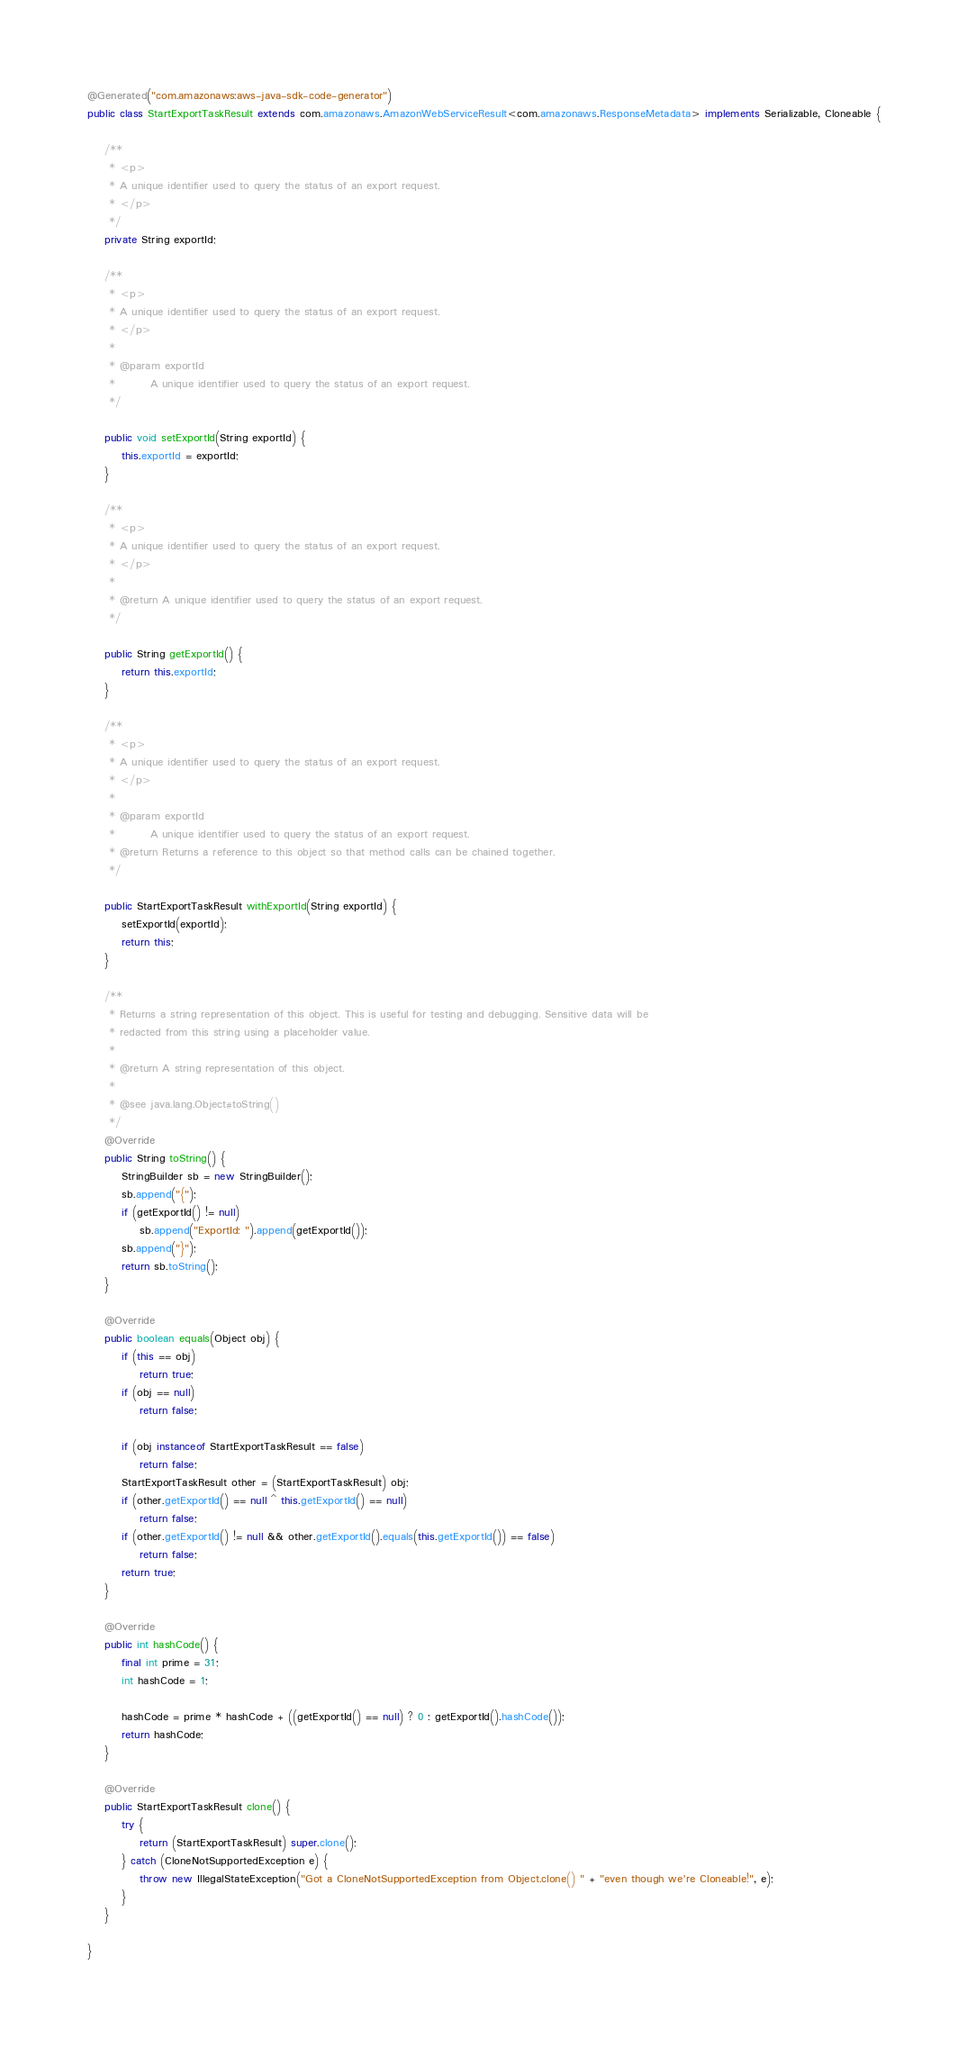<code> <loc_0><loc_0><loc_500><loc_500><_Java_>
@Generated("com.amazonaws:aws-java-sdk-code-generator")
public class StartExportTaskResult extends com.amazonaws.AmazonWebServiceResult<com.amazonaws.ResponseMetadata> implements Serializable, Cloneable {

    /**
     * <p>
     * A unique identifier used to query the status of an export request.
     * </p>
     */
    private String exportId;

    /**
     * <p>
     * A unique identifier used to query the status of an export request.
     * </p>
     * 
     * @param exportId
     *        A unique identifier used to query the status of an export request.
     */

    public void setExportId(String exportId) {
        this.exportId = exportId;
    }

    /**
     * <p>
     * A unique identifier used to query the status of an export request.
     * </p>
     * 
     * @return A unique identifier used to query the status of an export request.
     */

    public String getExportId() {
        return this.exportId;
    }

    /**
     * <p>
     * A unique identifier used to query the status of an export request.
     * </p>
     * 
     * @param exportId
     *        A unique identifier used to query the status of an export request.
     * @return Returns a reference to this object so that method calls can be chained together.
     */

    public StartExportTaskResult withExportId(String exportId) {
        setExportId(exportId);
        return this;
    }

    /**
     * Returns a string representation of this object. This is useful for testing and debugging. Sensitive data will be
     * redacted from this string using a placeholder value.
     *
     * @return A string representation of this object.
     *
     * @see java.lang.Object#toString()
     */
    @Override
    public String toString() {
        StringBuilder sb = new StringBuilder();
        sb.append("{");
        if (getExportId() != null)
            sb.append("ExportId: ").append(getExportId());
        sb.append("}");
        return sb.toString();
    }

    @Override
    public boolean equals(Object obj) {
        if (this == obj)
            return true;
        if (obj == null)
            return false;

        if (obj instanceof StartExportTaskResult == false)
            return false;
        StartExportTaskResult other = (StartExportTaskResult) obj;
        if (other.getExportId() == null ^ this.getExportId() == null)
            return false;
        if (other.getExportId() != null && other.getExportId().equals(this.getExportId()) == false)
            return false;
        return true;
    }

    @Override
    public int hashCode() {
        final int prime = 31;
        int hashCode = 1;

        hashCode = prime * hashCode + ((getExportId() == null) ? 0 : getExportId().hashCode());
        return hashCode;
    }

    @Override
    public StartExportTaskResult clone() {
        try {
            return (StartExportTaskResult) super.clone();
        } catch (CloneNotSupportedException e) {
            throw new IllegalStateException("Got a CloneNotSupportedException from Object.clone() " + "even though we're Cloneable!", e);
        }
    }

}
</code> 